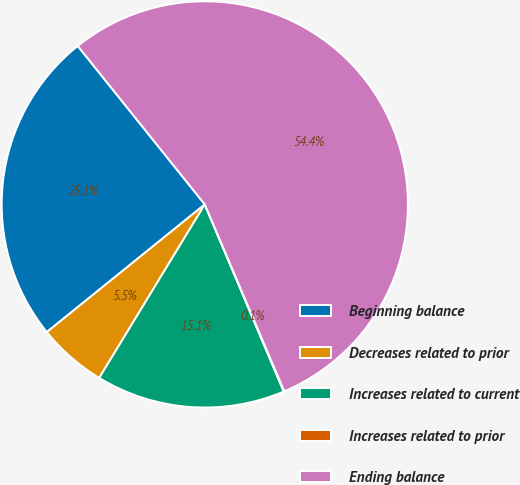Convert chart to OTSL. <chart><loc_0><loc_0><loc_500><loc_500><pie_chart><fcel>Beginning balance<fcel>Decreases related to prior<fcel>Increases related to current<fcel>Increases related to prior<fcel>Ending balance<nl><fcel>25.06%<fcel>5.48%<fcel>15.05%<fcel>0.05%<fcel>54.35%<nl></chart> 